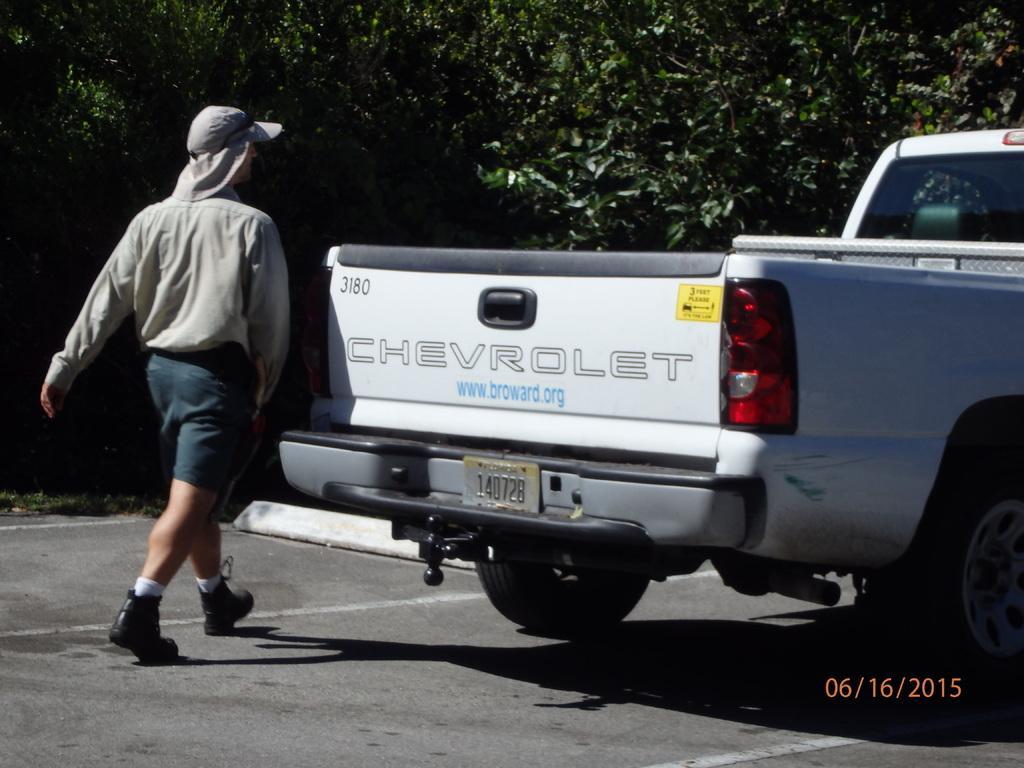Can you describe this image briefly? In this image I can see the vehicle and I can also see the person walking. In the background I can see few trees in green color. 